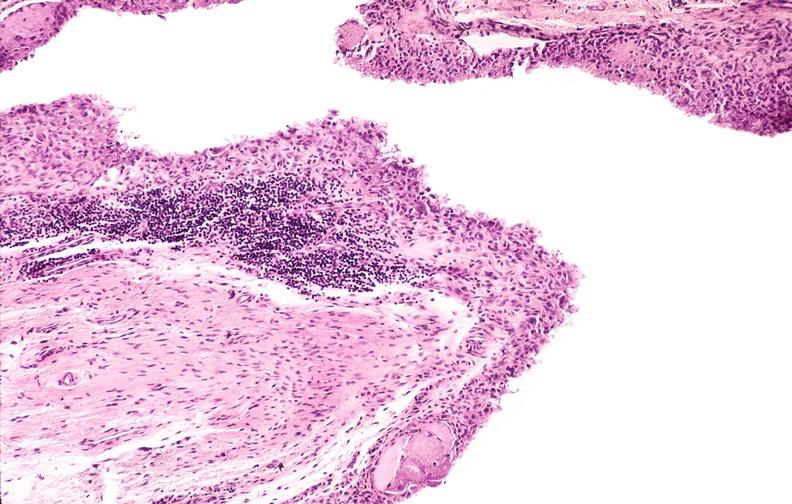does this image show rheumatoid arthritis, synovial hypertrophy with formation of villi pannus?
Answer the question using a single word or phrase. Yes 